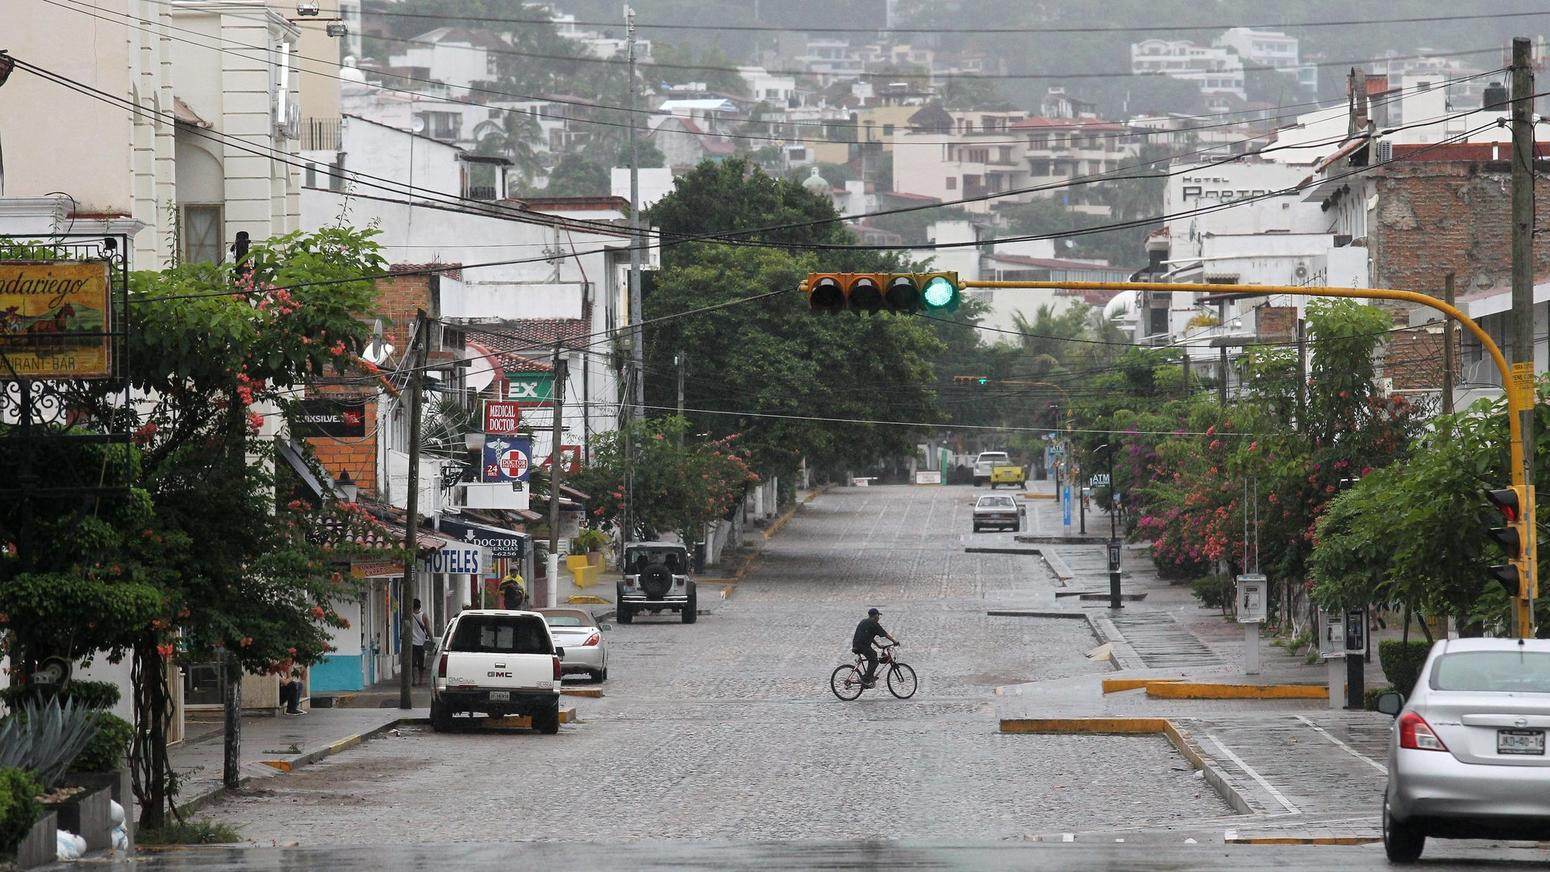Based on the visible signage, what types of services are available on this street, and how does the presence of these services inform us about the character of the neighborhood? The signage along the street indicates a blend of services crucial for both local residents and visitors: lodgings hinting at a possible tourist interest in the area are apparent through hotel signs, while the health needs of the community are catered to by a medical facility. The presence of a bar represents the hospitality and dining options, suggesting a social and possibly nightlife-oriented aspect of the neighborhood. The combination of these services tells us that this is a multifaceted neighborhood, likely balancing residential living with the comings and goings of visitors, which may enrich the local economy. Additionally, the wet streets and overcast sky depict a rainy day, which adds to the neighborhood's atmosphere, perhaps indicating a region with frequent precipitation that could affect daily life and local business patterns. 